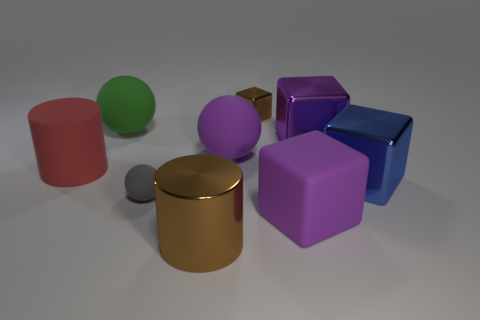Add 1 big gray blocks. How many objects exist? 10 Subtract all cubes. How many objects are left? 5 Add 4 large red cylinders. How many large red cylinders are left? 5 Add 7 big gray spheres. How many big gray spheres exist? 7 Subtract 1 gray balls. How many objects are left? 8 Subtract all gray shiny blocks. Subtract all big blue metal things. How many objects are left? 8 